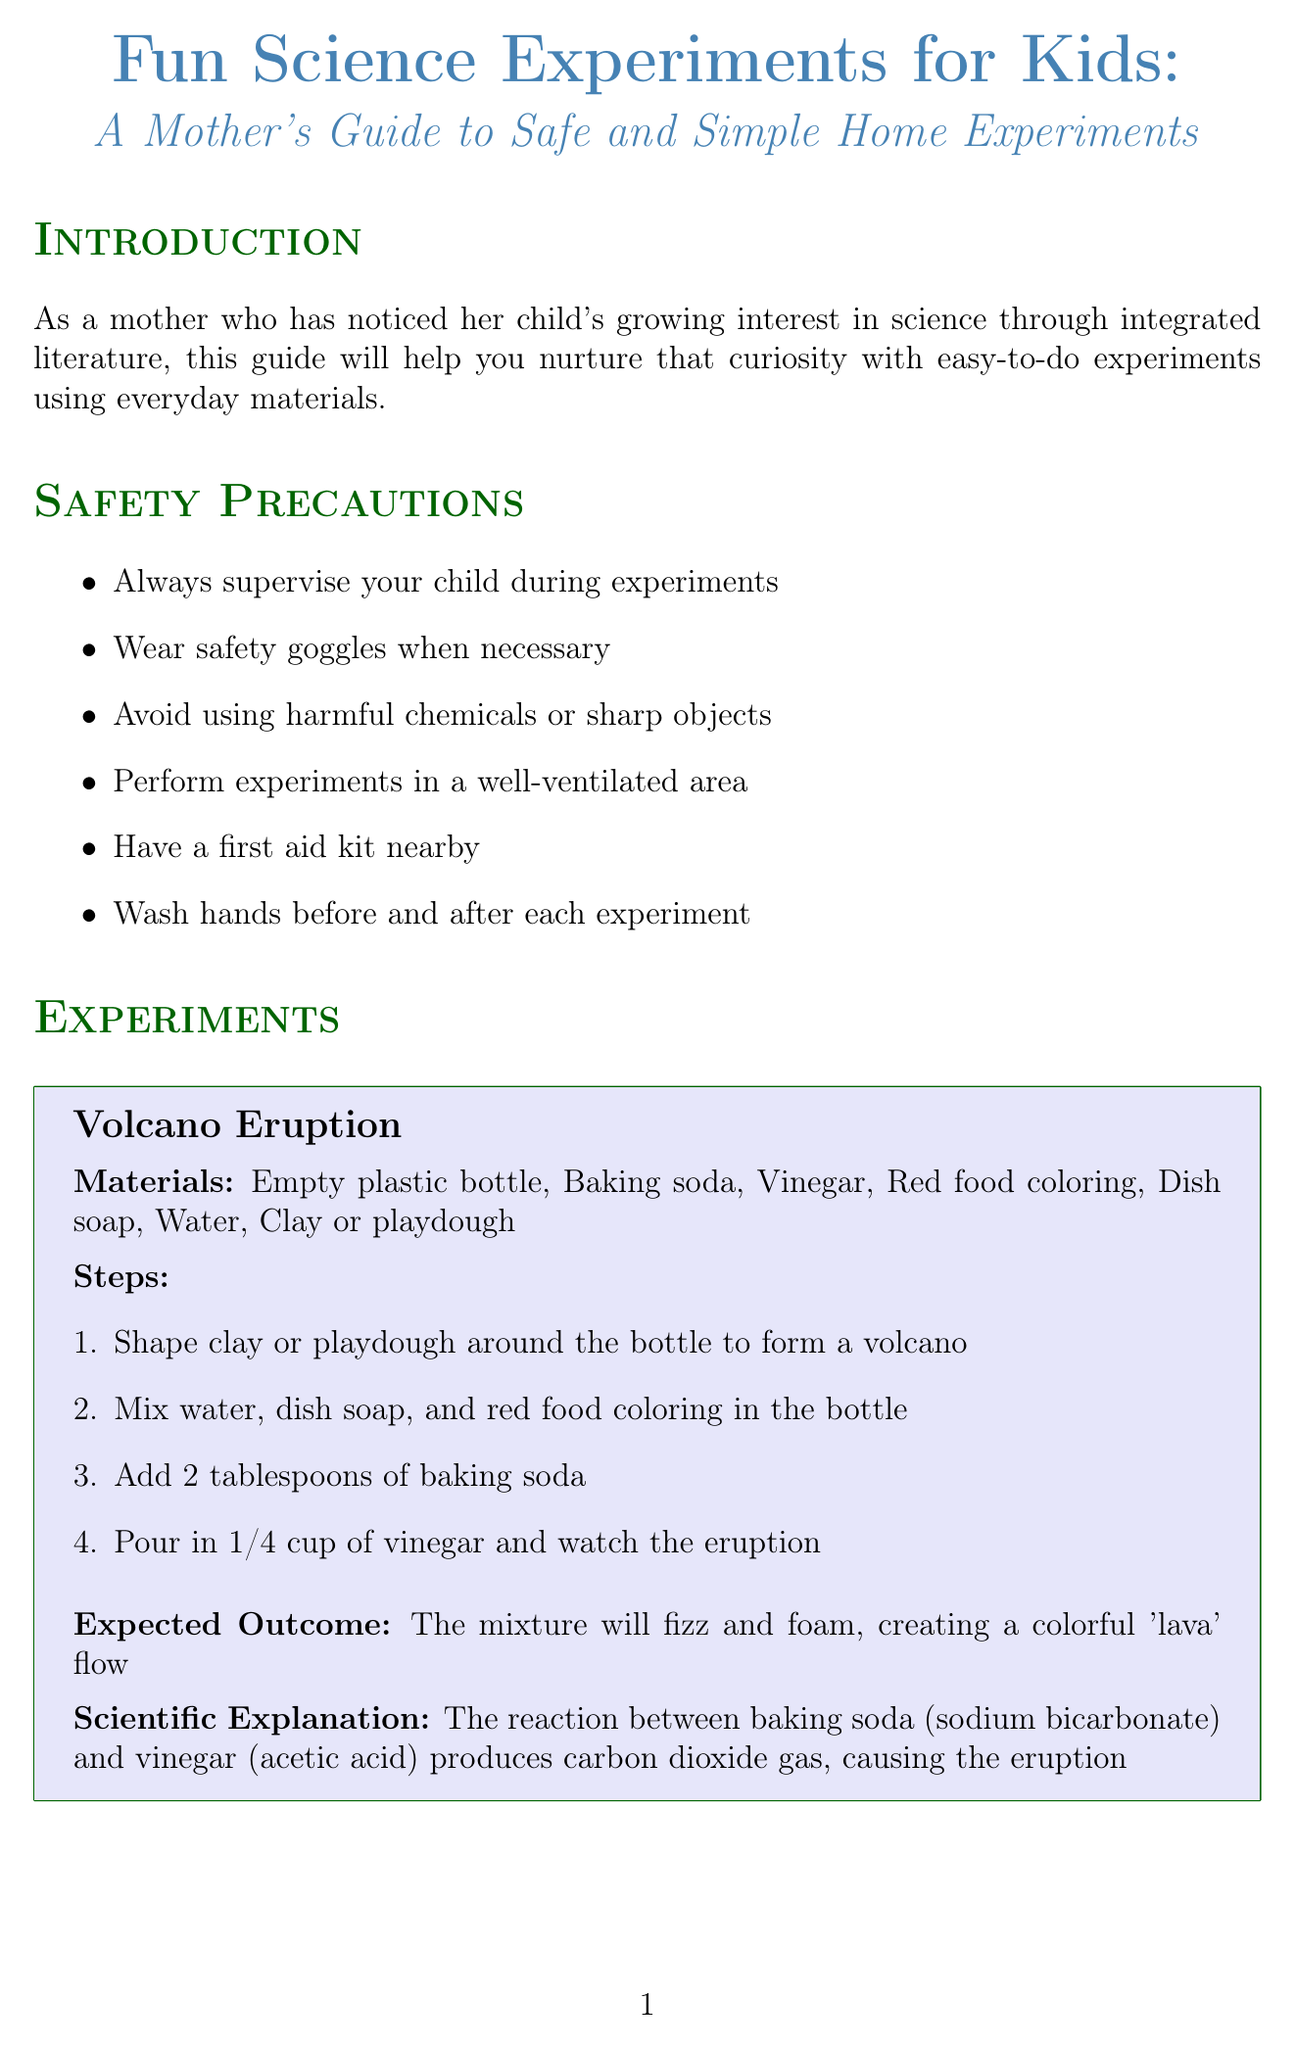what is the title of the guide? The title of the guide is mentioned at the beginning of the document.
Answer: Fun Science Experiments for Kids: A Mother's Guide to Safe and Simple Home Experiments how many safety precautions are listed? The document lists the various safety precautions to be taken during experiments.
Answer: six what is the expected outcome of the Volcano Eruption experiment? The expected outcome describes the results of performing the Volcano Eruption experiment.
Answer: The mixture will fizz and foam, creating a colorful 'lava' flow which ingredient is used to create the invisible ink? The document specifies the materials needed for the Invisible Ink experiment.
Answer: Lemon juice name one tip for parents included in the document. The tips provided for parents aim to enhance the learning experience for children performing experiments.
Answer: Relate experiments to stories or books your child enjoys what is the scientific explanation for the Rainbow in a Glass experiment? The document provides a scientific explanation for the results of the Rainbow in a Glass experiment.
Answer: Solutions with more dissolved sugar are denser and sink to the bottom, while less dense solutions float on top 